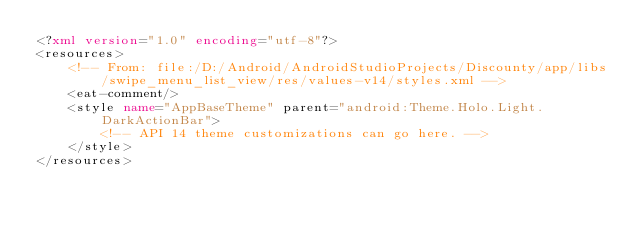<code> <loc_0><loc_0><loc_500><loc_500><_XML_><?xml version="1.0" encoding="utf-8"?>
<resources>
    <!-- From: file:/D:/Android/AndroidStudioProjects/Discounty/app/libs/swipe_menu_list_view/res/values-v14/styles.xml -->
    <eat-comment/>
    <style name="AppBaseTheme" parent="android:Theme.Holo.Light.DarkActionBar">
        <!-- API 14 theme customizations can go here. -->
    </style>
</resources></code> 